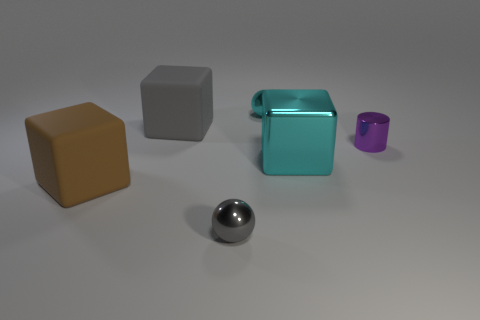What are the different textures that can be observed among the objects in the image? The image features objects with various textures: the large brown block has a matte finish; the gray object appears smooth; the glass-like blue object has a translucent, glossy texture; the purple cylinder has a slightly reflective surface, and the sphere in the foreground has a reflective, almost mirror-like finish. 